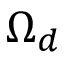Convert formula to latex. <formula><loc_0><loc_0><loc_500><loc_500>\Omega _ { d }</formula> 